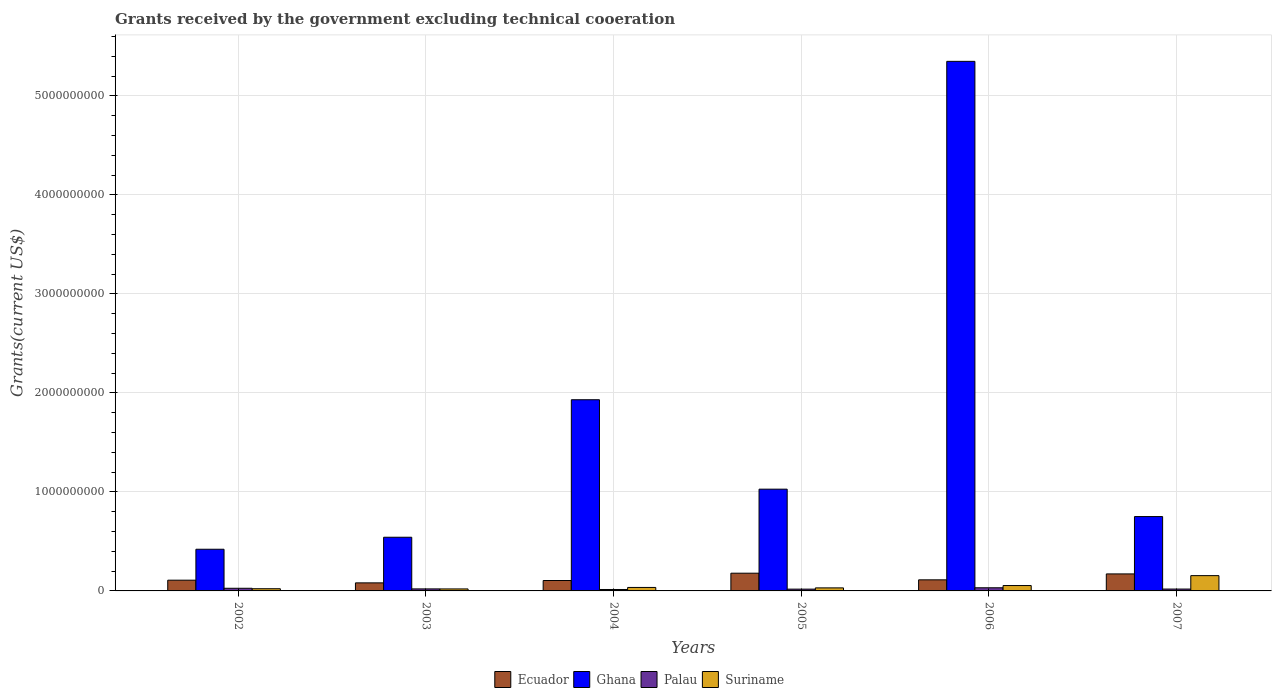How many groups of bars are there?
Keep it short and to the point. 6. Are the number of bars on each tick of the X-axis equal?
Make the answer very short. Yes. How many bars are there on the 4th tick from the left?
Make the answer very short. 4. What is the label of the 1st group of bars from the left?
Your answer should be very brief. 2002. What is the total grants received by the government in Palau in 2004?
Your response must be concise. 1.45e+07. Across all years, what is the maximum total grants received by the government in Palau?
Make the answer very short. 3.17e+07. Across all years, what is the minimum total grants received by the government in Palau?
Offer a very short reply. 1.45e+07. In which year was the total grants received by the government in Ecuador maximum?
Keep it short and to the point. 2005. In which year was the total grants received by the government in Palau minimum?
Your answer should be very brief. 2004. What is the total total grants received by the government in Ghana in the graph?
Provide a succinct answer. 1.00e+1. What is the difference between the total grants received by the government in Suriname in 2003 and that in 2005?
Ensure brevity in your answer.  -1.06e+07. What is the difference between the total grants received by the government in Ghana in 2007 and the total grants received by the government in Ecuador in 2004?
Ensure brevity in your answer.  6.46e+08. What is the average total grants received by the government in Suriname per year?
Keep it short and to the point. 5.28e+07. In the year 2003, what is the difference between the total grants received by the government in Ghana and total grants received by the government in Suriname?
Your response must be concise. 5.22e+08. What is the ratio of the total grants received by the government in Ecuador in 2006 to that in 2007?
Give a very brief answer. 0.65. What is the difference between the highest and the second highest total grants received by the government in Suriname?
Your answer should be compact. 1.00e+08. What is the difference between the highest and the lowest total grants received by the government in Ecuador?
Ensure brevity in your answer.  9.76e+07. What does the 4th bar from the left in 2005 represents?
Your response must be concise. Suriname. Is it the case that in every year, the sum of the total grants received by the government in Suriname and total grants received by the government in Palau is greater than the total grants received by the government in Ghana?
Provide a short and direct response. No. Are all the bars in the graph horizontal?
Your answer should be very brief. No. How many years are there in the graph?
Keep it short and to the point. 6. Does the graph contain grids?
Provide a succinct answer. Yes. How are the legend labels stacked?
Ensure brevity in your answer.  Horizontal. What is the title of the graph?
Your response must be concise. Grants received by the government excluding technical cooeration. What is the label or title of the Y-axis?
Your response must be concise. Grants(current US$). What is the Grants(current US$) of Ecuador in 2002?
Ensure brevity in your answer.  1.08e+08. What is the Grants(current US$) in Ghana in 2002?
Your answer should be very brief. 4.21e+08. What is the Grants(current US$) in Palau in 2002?
Your answer should be compact. 2.68e+07. What is the Grants(current US$) of Suriname in 2002?
Keep it short and to the point. 2.21e+07. What is the Grants(current US$) in Ecuador in 2003?
Keep it short and to the point. 8.14e+07. What is the Grants(current US$) in Ghana in 2003?
Give a very brief answer. 5.42e+08. What is the Grants(current US$) of Palau in 2003?
Give a very brief answer. 2.05e+07. What is the Grants(current US$) in Suriname in 2003?
Offer a very short reply. 2.02e+07. What is the Grants(current US$) in Ecuador in 2004?
Your answer should be very brief. 1.05e+08. What is the Grants(current US$) in Ghana in 2004?
Your answer should be very brief. 1.93e+09. What is the Grants(current US$) of Palau in 2004?
Keep it short and to the point. 1.45e+07. What is the Grants(current US$) of Suriname in 2004?
Provide a short and direct response. 3.52e+07. What is the Grants(current US$) in Ecuador in 2005?
Your answer should be compact. 1.79e+08. What is the Grants(current US$) of Ghana in 2005?
Provide a succinct answer. 1.03e+09. What is the Grants(current US$) in Palau in 2005?
Your answer should be compact. 1.81e+07. What is the Grants(current US$) of Suriname in 2005?
Give a very brief answer. 3.07e+07. What is the Grants(current US$) of Ecuador in 2006?
Provide a short and direct response. 1.12e+08. What is the Grants(current US$) of Ghana in 2006?
Provide a succinct answer. 5.35e+09. What is the Grants(current US$) in Palau in 2006?
Offer a terse response. 3.17e+07. What is the Grants(current US$) in Suriname in 2006?
Ensure brevity in your answer.  5.43e+07. What is the Grants(current US$) in Ecuador in 2007?
Offer a very short reply. 1.72e+08. What is the Grants(current US$) in Ghana in 2007?
Provide a short and direct response. 7.51e+08. What is the Grants(current US$) of Palau in 2007?
Offer a terse response. 1.89e+07. What is the Grants(current US$) of Suriname in 2007?
Keep it short and to the point. 1.54e+08. Across all years, what is the maximum Grants(current US$) of Ecuador?
Make the answer very short. 1.79e+08. Across all years, what is the maximum Grants(current US$) in Ghana?
Provide a succinct answer. 5.35e+09. Across all years, what is the maximum Grants(current US$) of Palau?
Your answer should be compact. 3.17e+07. Across all years, what is the maximum Grants(current US$) of Suriname?
Make the answer very short. 1.54e+08. Across all years, what is the minimum Grants(current US$) in Ecuador?
Make the answer very short. 8.14e+07. Across all years, what is the minimum Grants(current US$) in Ghana?
Ensure brevity in your answer.  4.21e+08. Across all years, what is the minimum Grants(current US$) in Palau?
Make the answer very short. 1.45e+07. Across all years, what is the minimum Grants(current US$) in Suriname?
Offer a very short reply. 2.02e+07. What is the total Grants(current US$) of Ecuador in the graph?
Your answer should be very brief. 7.58e+08. What is the total Grants(current US$) in Ghana in the graph?
Your answer should be compact. 1.00e+1. What is the total Grants(current US$) in Palau in the graph?
Your response must be concise. 1.30e+08. What is the total Grants(current US$) in Suriname in the graph?
Your response must be concise. 3.17e+08. What is the difference between the Grants(current US$) of Ecuador in 2002 and that in 2003?
Make the answer very short. 2.71e+07. What is the difference between the Grants(current US$) in Ghana in 2002 and that in 2003?
Make the answer very short. -1.21e+08. What is the difference between the Grants(current US$) in Palau in 2002 and that in 2003?
Offer a very short reply. 6.28e+06. What is the difference between the Grants(current US$) in Suriname in 2002 and that in 2003?
Provide a succinct answer. 1.93e+06. What is the difference between the Grants(current US$) of Ecuador in 2002 and that in 2004?
Provide a succinct answer. 3.24e+06. What is the difference between the Grants(current US$) of Ghana in 2002 and that in 2004?
Provide a succinct answer. -1.51e+09. What is the difference between the Grants(current US$) in Palau in 2002 and that in 2004?
Your answer should be compact. 1.22e+07. What is the difference between the Grants(current US$) of Suriname in 2002 and that in 2004?
Your answer should be compact. -1.31e+07. What is the difference between the Grants(current US$) in Ecuador in 2002 and that in 2005?
Make the answer very short. -7.05e+07. What is the difference between the Grants(current US$) of Ghana in 2002 and that in 2005?
Your answer should be very brief. -6.07e+08. What is the difference between the Grants(current US$) of Palau in 2002 and that in 2005?
Your response must be concise. 8.67e+06. What is the difference between the Grants(current US$) of Suriname in 2002 and that in 2005?
Offer a very short reply. -8.63e+06. What is the difference between the Grants(current US$) of Ecuador in 2002 and that in 2006?
Offer a very short reply. -3.44e+06. What is the difference between the Grants(current US$) of Ghana in 2002 and that in 2006?
Your answer should be very brief. -4.93e+09. What is the difference between the Grants(current US$) in Palau in 2002 and that in 2006?
Make the answer very short. -4.99e+06. What is the difference between the Grants(current US$) in Suriname in 2002 and that in 2006?
Give a very brief answer. -3.22e+07. What is the difference between the Grants(current US$) of Ecuador in 2002 and that in 2007?
Your response must be concise. -6.33e+07. What is the difference between the Grants(current US$) of Ghana in 2002 and that in 2007?
Your answer should be compact. -3.30e+08. What is the difference between the Grants(current US$) in Palau in 2002 and that in 2007?
Make the answer very short. 7.89e+06. What is the difference between the Grants(current US$) in Suriname in 2002 and that in 2007?
Give a very brief answer. -1.32e+08. What is the difference between the Grants(current US$) of Ecuador in 2003 and that in 2004?
Keep it short and to the point. -2.39e+07. What is the difference between the Grants(current US$) of Ghana in 2003 and that in 2004?
Provide a short and direct response. -1.39e+09. What is the difference between the Grants(current US$) in Palau in 2003 and that in 2004?
Your answer should be compact. 5.96e+06. What is the difference between the Grants(current US$) of Suriname in 2003 and that in 2004?
Give a very brief answer. -1.50e+07. What is the difference between the Grants(current US$) in Ecuador in 2003 and that in 2005?
Your response must be concise. -9.76e+07. What is the difference between the Grants(current US$) in Ghana in 2003 and that in 2005?
Offer a very short reply. -4.85e+08. What is the difference between the Grants(current US$) in Palau in 2003 and that in 2005?
Provide a succinct answer. 2.39e+06. What is the difference between the Grants(current US$) of Suriname in 2003 and that in 2005?
Make the answer very short. -1.06e+07. What is the difference between the Grants(current US$) of Ecuador in 2003 and that in 2006?
Make the answer very short. -3.06e+07. What is the difference between the Grants(current US$) of Ghana in 2003 and that in 2006?
Your response must be concise. -4.81e+09. What is the difference between the Grants(current US$) of Palau in 2003 and that in 2006?
Your response must be concise. -1.13e+07. What is the difference between the Grants(current US$) in Suriname in 2003 and that in 2006?
Provide a short and direct response. -3.42e+07. What is the difference between the Grants(current US$) in Ecuador in 2003 and that in 2007?
Make the answer very short. -9.04e+07. What is the difference between the Grants(current US$) in Ghana in 2003 and that in 2007?
Offer a very short reply. -2.09e+08. What is the difference between the Grants(current US$) of Palau in 2003 and that in 2007?
Your answer should be very brief. 1.61e+06. What is the difference between the Grants(current US$) of Suriname in 2003 and that in 2007?
Your response must be concise. -1.34e+08. What is the difference between the Grants(current US$) in Ecuador in 2004 and that in 2005?
Ensure brevity in your answer.  -7.37e+07. What is the difference between the Grants(current US$) of Ghana in 2004 and that in 2005?
Provide a short and direct response. 9.03e+08. What is the difference between the Grants(current US$) in Palau in 2004 and that in 2005?
Provide a short and direct response. -3.57e+06. What is the difference between the Grants(current US$) in Suriname in 2004 and that in 2005?
Make the answer very short. 4.44e+06. What is the difference between the Grants(current US$) of Ecuador in 2004 and that in 2006?
Give a very brief answer. -6.68e+06. What is the difference between the Grants(current US$) in Ghana in 2004 and that in 2006?
Keep it short and to the point. -3.42e+09. What is the difference between the Grants(current US$) in Palau in 2004 and that in 2006?
Your answer should be compact. -1.72e+07. What is the difference between the Grants(current US$) of Suriname in 2004 and that in 2006?
Your answer should be compact. -1.92e+07. What is the difference between the Grants(current US$) of Ecuador in 2004 and that in 2007?
Your answer should be very brief. -6.65e+07. What is the difference between the Grants(current US$) in Ghana in 2004 and that in 2007?
Your answer should be very brief. 1.18e+09. What is the difference between the Grants(current US$) in Palau in 2004 and that in 2007?
Provide a short and direct response. -4.35e+06. What is the difference between the Grants(current US$) of Suriname in 2004 and that in 2007?
Keep it short and to the point. -1.19e+08. What is the difference between the Grants(current US$) in Ecuador in 2005 and that in 2006?
Provide a short and direct response. 6.70e+07. What is the difference between the Grants(current US$) in Ghana in 2005 and that in 2006?
Offer a terse response. -4.32e+09. What is the difference between the Grants(current US$) in Palau in 2005 and that in 2006?
Offer a terse response. -1.37e+07. What is the difference between the Grants(current US$) in Suriname in 2005 and that in 2006?
Your response must be concise. -2.36e+07. What is the difference between the Grants(current US$) of Ecuador in 2005 and that in 2007?
Keep it short and to the point. 7.21e+06. What is the difference between the Grants(current US$) in Ghana in 2005 and that in 2007?
Provide a succinct answer. 2.77e+08. What is the difference between the Grants(current US$) in Palau in 2005 and that in 2007?
Keep it short and to the point. -7.80e+05. What is the difference between the Grants(current US$) of Suriname in 2005 and that in 2007?
Offer a very short reply. -1.24e+08. What is the difference between the Grants(current US$) in Ecuador in 2006 and that in 2007?
Ensure brevity in your answer.  -5.98e+07. What is the difference between the Grants(current US$) in Ghana in 2006 and that in 2007?
Keep it short and to the point. 4.60e+09. What is the difference between the Grants(current US$) of Palau in 2006 and that in 2007?
Keep it short and to the point. 1.29e+07. What is the difference between the Grants(current US$) in Suriname in 2006 and that in 2007?
Your response must be concise. -1.00e+08. What is the difference between the Grants(current US$) in Ecuador in 2002 and the Grants(current US$) in Ghana in 2003?
Make the answer very short. -4.34e+08. What is the difference between the Grants(current US$) of Ecuador in 2002 and the Grants(current US$) of Palau in 2003?
Keep it short and to the point. 8.80e+07. What is the difference between the Grants(current US$) of Ecuador in 2002 and the Grants(current US$) of Suriname in 2003?
Give a very brief answer. 8.83e+07. What is the difference between the Grants(current US$) of Ghana in 2002 and the Grants(current US$) of Palau in 2003?
Give a very brief answer. 4.00e+08. What is the difference between the Grants(current US$) of Ghana in 2002 and the Grants(current US$) of Suriname in 2003?
Offer a very short reply. 4.01e+08. What is the difference between the Grants(current US$) in Palau in 2002 and the Grants(current US$) in Suriname in 2003?
Make the answer very short. 6.59e+06. What is the difference between the Grants(current US$) in Ecuador in 2002 and the Grants(current US$) in Ghana in 2004?
Give a very brief answer. -1.82e+09. What is the difference between the Grants(current US$) in Ecuador in 2002 and the Grants(current US$) in Palau in 2004?
Provide a succinct answer. 9.40e+07. What is the difference between the Grants(current US$) in Ecuador in 2002 and the Grants(current US$) in Suriname in 2004?
Keep it short and to the point. 7.33e+07. What is the difference between the Grants(current US$) in Ghana in 2002 and the Grants(current US$) in Palau in 2004?
Keep it short and to the point. 4.06e+08. What is the difference between the Grants(current US$) in Ghana in 2002 and the Grants(current US$) in Suriname in 2004?
Your answer should be compact. 3.86e+08. What is the difference between the Grants(current US$) of Palau in 2002 and the Grants(current US$) of Suriname in 2004?
Give a very brief answer. -8.41e+06. What is the difference between the Grants(current US$) in Ecuador in 2002 and the Grants(current US$) in Ghana in 2005?
Your answer should be very brief. -9.19e+08. What is the difference between the Grants(current US$) in Ecuador in 2002 and the Grants(current US$) in Palau in 2005?
Give a very brief answer. 9.04e+07. What is the difference between the Grants(current US$) in Ecuador in 2002 and the Grants(current US$) in Suriname in 2005?
Offer a very short reply. 7.77e+07. What is the difference between the Grants(current US$) in Ghana in 2002 and the Grants(current US$) in Palau in 2005?
Your answer should be compact. 4.03e+08. What is the difference between the Grants(current US$) in Ghana in 2002 and the Grants(current US$) in Suriname in 2005?
Keep it short and to the point. 3.90e+08. What is the difference between the Grants(current US$) of Palau in 2002 and the Grants(current US$) of Suriname in 2005?
Your response must be concise. -3.97e+06. What is the difference between the Grants(current US$) in Ecuador in 2002 and the Grants(current US$) in Ghana in 2006?
Ensure brevity in your answer.  -5.24e+09. What is the difference between the Grants(current US$) of Ecuador in 2002 and the Grants(current US$) of Palau in 2006?
Your answer should be very brief. 7.67e+07. What is the difference between the Grants(current US$) in Ecuador in 2002 and the Grants(current US$) in Suriname in 2006?
Ensure brevity in your answer.  5.41e+07. What is the difference between the Grants(current US$) in Ghana in 2002 and the Grants(current US$) in Palau in 2006?
Your answer should be compact. 3.89e+08. What is the difference between the Grants(current US$) in Ghana in 2002 and the Grants(current US$) in Suriname in 2006?
Provide a short and direct response. 3.67e+08. What is the difference between the Grants(current US$) of Palau in 2002 and the Grants(current US$) of Suriname in 2006?
Offer a terse response. -2.76e+07. What is the difference between the Grants(current US$) of Ecuador in 2002 and the Grants(current US$) of Ghana in 2007?
Offer a terse response. -6.42e+08. What is the difference between the Grants(current US$) in Ecuador in 2002 and the Grants(current US$) in Palau in 2007?
Provide a short and direct response. 8.96e+07. What is the difference between the Grants(current US$) in Ecuador in 2002 and the Grants(current US$) in Suriname in 2007?
Make the answer very short. -4.60e+07. What is the difference between the Grants(current US$) in Ghana in 2002 and the Grants(current US$) in Palau in 2007?
Your response must be concise. 4.02e+08. What is the difference between the Grants(current US$) of Ghana in 2002 and the Grants(current US$) of Suriname in 2007?
Your answer should be compact. 2.66e+08. What is the difference between the Grants(current US$) of Palau in 2002 and the Grants(current US$) of Suriname in 2007?
Your answer should be very brief. -1.28e+08. What is the difference between the Grants(current US$) in Ecuador in 2003 and the Grants(current US$) in Ghana in 2004?
Your answer should be compact. -1.85e+09. What is the difference between the Grants(current US$) of Ecuador in 2003 and the Grants(current US$) of Palau in 2004?
Offer a very short reply. 6.68e+07. What is the difference between the Grants(current US$) of Ecuador in 2003 and the Grants(current US$) of Suriname in 2004?
Your response must be concise. 4.62e+07. What is the difference between the Grants(current US$) of Ghana in 2003 and the Grants(current US$) of Palau in 2004?
Offer a terse response. 5.28e+08. What is the difference between the Grants(current US$) of Ghana in 2003 and the Grants(current US$) of Suriname in 2004?
Give a very brief answer. 5.07e+08. What is the difference between the Grants(current US$) of Palau in 2003 and the Grants(current US$) of Suriname in 2004?
Your answer should be compact. -1.47e+07. What is the difference between the Grants(current US$) in Ecuador in 2003 and the Grants(current US$) in Ghana in 2005?
Provide a succinct answer. -9.46e+08. What is the difference between the Grants(current US$) in Ecuador in 2003 and the Grants(current US$) in Palau in 2005?
Provide a succinct answer. 6.33e+07. What is the difference between the Grants(current US$) in Ecuador in 2003 and the Grants(current US$) in Suriname in 2005?
Keep it short and to the point. 5.06e+07. What is the difference between the Grants(current US$) in Ghana in 2003 and the Grants(current US$) in Palau in 2005?
Provide a succinct answer. 5.24e+08. What is the difference between the Grants(current US$) of Ghana in 2003 and the Grants(current US$) of Suriname in 2005?
Keep it short and to the point. 5.11e+08. What is the difference between the Grants(current US$) of Palau in 2003 and the Grants(current US$) of Suriname in 2005?
Your answer should be compact. -1.02e+07. What is the difference between the Grants(current US$) of Ecuador in 2003 and the Grants(current US$) of Ghana in 2006?
Keep it short and to the point. -5.27e+09. What is the difference between the Grants(current US$) in Ecuador in 2003 and the Grants(current US$) in Palau in 2006?
Provide a short and direct response. 4.96e+07. What is the difference between the Grants(current US$) of Ecuador in 2003 and the Grants(current US$) of Suriname in 2006?
Make the answer very short. 2.70e+07. What is the difference between the Grants(current US$) in Ghana in 2003 and the Grants(current US$) in Palau in 2006?
Your response must be concise. 5.10e+08. What is the difference between the Grants(current US$) in Ghana in 2003 and the Grants(current US$) in Suriname in 2006?
Keep it short and to the point. 4.88e+08. What is the difference between the Grants(current US$) in Palau in 2003 and the Grants(current US$) in Suriname in 2006?
Your answer should be compact. -3.38e+07. What is the difference between the Grants(current US$) in Ecuador in 2003 and the Grants(current US$) in Ghana in 2007?
Offer a very short reply. -6.70e+08. What is the difference between the Grants(current US$) of Ecuador in 2003 and the Grants(current US$) of Palau in 2007?
Your answer should be compact. 6.25e+07. What is the difference between the Grants(current US$) of Ecuador in 2003 and the Grants(current US$) of Suriname in 2007?
Give a very brief answer. -7.31e+07. What is the difference between the Grants(current US$) in Ghana in 2003 and the Grants(current US$) in Palau in 2007?
Provide a succinct answer. 5.23e+08. What is the difference between the Grants(current US$) of Ghana in 2003 and the Grants(current US$) of Suriname in 2007?
Offer a very short reply. 3.88e+08. What is the difference between the Grants(current US$) of Palau in 2003 and the Grants(current US$) of Suriname in 2007?
Your answer should be compact. -1.34e+08. What is the difference between the Grants(current US$) of Ecuador in 2004 and the Grants(current US$) of Ghana in 2005?
Your response must be concise. -9.22e+08. What is the difference between the Grants(current US$) in Ecuador in 2004 and the Grants(current US$) in Palau in 2005?
Keep it short and to the point. 8.71e+07. What is the difference between the Grants(current US$) of Ecuador in 2004 and the Grants(current US$) of Suriname in 2005?
Ensure brevity in your answer.  7.45e+07. What is the difference between the Grants(current US$) in Ghana in 2004 and the Grants(current US$) in Palau in 2005?
Offer a very short reply. 1.91e+09. What is the difference between the Grants(current US$) of Ghana in 2004 and the Grants(current US$) of Suriname in 2005?
Your answer should be compact. 1.90e+09. What is the difference between the Grants(current US$) of Palau in 2004 and the Grants(current US$) of Suriname in 2005?
Make the answer very short. -1.62e+07. What is the difference between the Grants(current US$) of Ecuador in 2004 and the Grants(current US$) of Ghana in 2006?
Provide a succinct answer. -5.24e+09. What is the difference between the Grants(current US$) in Ecuador in 2004 and the Grants(current US$) in Palau in 2006?
Keep it short and to the point. 7.35e+07. What is the difference between the Grants(current US$) of Ecuador in 2004 and the Grants(current US$) of Suriname in 2006?
Provide a succinct answer. 5.09e+07. What is the difference between the Grants(current US$) in Ghana in 2004 and the Grants(current US$) in Palau in 2006?
Offer a very short reply. 1.90e+09. What is the difference between the Grants(current US$) in Ghana in 2004 and the Grants(current US$) in Suriname in 2006?
Ensure brevity in your answer.  1.88e+09. What is the difference between the Grants(current US$) of Palau in 2004 and the Grants(current US$) of Suriname in 2006?
Your answer should be very brief. -3.98e+07. What is the difference between the Grants(current US$) in Ecuador in 2004 and the Grants(current US$) in Ghana in 2007?
Your answer should be very brief. -6.46e+08. What is the difference between the Grants(current US$) of Ecuador in 2004 and the Grants(current US$) of Palau in 2007?
Give a very brief answer. 8.64e+07. What is the difference between the Grants(current US$) of Ecuador in 2004 and the Grants(current US$) of Suriname in 2007?
Your response must be concise. -4.92e+07. What is the difference between the Grants(current US$) of Ghana in 2004 and the Grants(current US$) of Palau in 2007?
Your response must be concise. 1.91e+09. What is the difference between the Grants(current US$) in Ghana in 2004 and the Grants(current US$) in Suriname in 2007?
Provide a succinct answer. 1.78e+09. What is the difference between the Grants(current US$) of Palau in 2004 and the Grants(current US$) of Suriname in 2007?
Give a very brief answer. -1.40e+08. What is the difference between the Grants(current US$) of Ecuador in 2005 and the Grants(current US$) of Ghana in 2006?
Give a very brief answer. -5.17e+09. What is the difference between the Grants(current US$) in Ecuador in 2005 and the Grants(current US$) in Palau in 2006?
Give a very brief answer. 1.47e+08. What is the difference between the Grants(current US$) in Ecuador in 2005 and the Grants(current US$) in Suriname in 2006?
Your response must be concise. 1.25e+08. What is the difference between the Grants(current US$) in Ghana in 2005 and the Grants(current US$) in Palau in 2006?
Your response must be concise. 9.96e+08. What is the difference between the Grants(current US$) in Ghana in 2005 and the Grants(current US$) in Suriname in 2006?
Offer a terse response. 9.73e+08. What is the difference between the Grants(current US$) of Palau in 2005 and the Grants(current US$) of Suriname in 2006?
Provide a short and direct response. -3.62e+07. What is the difference between the Grants(current US$) of Ecuador in 2005 and the Grants(current US$) of Ghana in 2007?
Give a very brief answer. -5.72e+08. What is the difference between the Grants(current US$) of Ecuador in 2005 and the Grants(current US$) of Palau in 2007?
Provide a short and direct response. 1.60e+08. What is the difference between the Grants(current US$) of Ecuador in 2005 and the Grants(current US$) of Suriname in 2007?
Your answer should be very brief. 2.45e+07. What is the difference between the Grants(current US$) of Ghana in 2005 and the Grants(current US$) of Palau in 2007?
Make the answer very short. 1.01e+09. What is the difference between the Grants(current US$) of Ghana in 2005 and the Grants(current US$) of Suriname in 2007?
Give a very brief answer. 8.73e+08. What is the difference between the Grants(current US$) of Palau in 2005 and the Grants(current US$) of Suriname in 2007?
Keep it short and to the point. -1.36e+08. What is the difference between the Grants(current US$) of Ecuador in 2006 and the Grants(current US$) of Ghana in 2007?
Your answer should be very brief. -6.39e+08. What is the difference between the Grants(current US$) of Ecuador in 2006 and the Grants(current US$) of Palau in 2007?
Your answer should be very brief. 9.30e+07. What is the difference between the Grants(current US$) in Ecuador in 2006 and the Grants(current US$) in Suriname in 2007?
Make the answer very short. -4.26e+07. What is the difference between the Grants(current US$) of Ghana in 2006 and the Grants(current US$) of Palau in 2007?
Your answer should be very brief. 5.33e+09. What is the difference between the Grants(current US$) of Ghana in 2006 and the Grants(current US$) of Suriname in 2007?
Offer a terse response. 5.19e+09. What is the difference between the Grants(current US$) in Palau in 2006 and the Grants(current US$) in Suriname in 2007?
Make the answer very short. -1.23e+08. What is the average Grants(current US$) of Ecuador per year?
Your answer should be compact. 1.26e+08. What is the average Grants(current US$) in Ghana per year?
Make the answer very short. 1.67e+09. What is the average Grants(current US$) of Palau per year?
Make the answer very short. 2.17e+07. What is the average Grants(current US$) of Suriname per year?
Your answer should be compact. 5.28e+07. In the year 2002, what is the difference between the Grants(current US$) of Ecuador and Grants(current US$) of Ghana?
Provide a short and direct response. -3.12e+08. In the year 2002, what is the difference between the Grants(current US$) of Ecuador and Grants(current US$) of Palau?
Keep it short and to the point. 8.17e+07. In the year 2002, what is the difference between the Grants(current US$) of Ecuador and Grants(current US$) of Suriname?
Provide a short and direct response. 8.64e+07. In the year 2002, what is the difference between the Grants(current US$) of Ghana and Grants(current US$) of Palau?
Provide a short and direct response. 3.94e+08. In the year 2002, what is the difference between the Grants(current US$) of Ghana and Grants(current US$) of Suriname?
Keep it short and to the point. 3.99e+08. In the year 2002, what is the difference between the Grants(current US$) of Palau and Grants(current US$) of Suriname?
Ensure brevity in your answer.  4.66e+06. In the year 2003, what is the difference between the Grants(current US$) in Ecuador and Grants(current US$) in Ghana?
Provide a succinct answer. -4.61e+08. In the year 2003, what is the difference between the Grants(current US$) of Ecuador and Grants(current US$) of Palau?
Offer a terse response. 6.09e+07. In the year 2003, what is the difference between the Grants(current US$) of Ecuador and Grants(current US$) of Suriname?
Give a very brief answer. 6.12e+07. In the year 2003, what is the difference between the Grants(current US$) of Ghana and Grants(current US$) of Palau?
Your response must be concise. 5.22e+08. In the year 2003, what is the difference between the Grants(current US$) of Ghana and Grants(current US$) of Suriname?
Give a very brief answer. 5.22e+08. In the year 2004, what is the difference between the Grants(current US$) in Ecuador and Grants(current US$) in Ghana?
Give a very brief answer. -1.83e+09. In the year 2004, what is the difference between the Grants(current US$) in Ecuador and Grants(current US$) in Palau?
Your answer should be very brief. 9.07e+07. In the year 2004, what is the difference between the Grants(current US$) in Ecuador and Grants(current US$) in Suriname?
Offer a very short reply. 7.01e+07. In the year 2004, what is the difference between the Grants(current US$) in Ghana and Grants(current US$) in Palau?
Give a very brief answer. 1.92e+09. In the year 2004, what is the difference between the Grants(current US$) of Ghana and Grants(current US$) of Suriname?
Give a very brief answer. 1.90e+09. In the year 2004, what is the difference between the Grants(current US$) in Palau and Grants(current US$) in Suriname?
Offer a very short reply. -2.06e+07. In the year 2005, what is the difference between the Grants(current US$) of Ecuador and Grants(current US$) of Ghana?
Your response must be concise. -8.49e+08. In the year 2005, what is the difference between the Grants(current US$) of Ecuador and Grants(current US$) of Palau?
Keep it short and to the point. 1.61e+08. In the year 2005, what is the difference between the Grants(current US$) in Ecuador and Grants(current US$) in Suriname?
Provide a succinct answer. 1.48e+08. In the year 2005, what is the difference between the Grants(current US$) in Ghana and Grants(current US$) in Palau?
Make the answer very short. 1.01e+09. In the year 2005, what is the difference between the Grants(current US$) in Ghana and Grants(current US$) in Suriname?
Give a very brief answer. 9.97e+08. In the year 2005, what is the difference between the Grants(current US$) in Palau and Grants(current US$) in Suriname?
Provide a succinct answer. -1.26e+07. In the year 2006, what is the difference between the Grants(current US$) of Ecuador and Grants(current US$) of Ghana?
Your answer should be compact. -5.24e+09. In the year 2006, what is the difference between the Grants(current US$) of Ecuador and Grants(current US$) of Palau?
Your response must be concise. 8.02e+07. In the year 2006, what is the difference between the Grants(current US$) of Ecuador and Grants(current US$) of Suriname?
Give a very brief answer. 5.76e+07. In the year 2006, what is the difference between the Grants(current US$) in Ghana and Grants(current US$) in Palau?
Your response must be concise. 5.32e+09. In the year 2006, what is the difference between the Grants(current US$) in Ghana and Grants(current US$) in Suriname?
Your response must be concise. 5.29e+09. In the year 2006, what is the difference between the Grants(current US$) of Palau and Grants(current US$) of Suriname?
Provide a short and direct response. -2.26e+07. In the year 2007, what is the difference between the Grants(current US$) of Ecuador and Grants(current US$) of Ghana?
Provide a short and direct response. -5.79e+08. In the year 2007, what is the difference between the Grants(current US$) of Ecuador and Grants(current US$) of Palau?
Ensure brevity in your answer.  1.53e+08. In the year 2007, what is the difference between the Grants(current US$) of Ecuador and Grants(current US$) of Suriname?
Your answer should be compact. 1.73e+07. In the year 2007, what is the difference between the Grants(current US$) of Ghana and Grants(current US$) of Palau?
Ensure brevity in your answer.  7.32e+08. In the year 2007, what is the difference between the Grants(current US$) of Ghana and Grants(current US$) of Suriname?
Provide a short and direct response. 5.96e+08. In the year 2007, what is the difference between the Grants(current US$) of Palau and Grants(current US$) of Suriname?
Ensure brevity in your answer.  -1.36e+08. What is the ratio of the Grants(current US$) of Ghana in 2002 to that in 2003?
Provide a short and direct response. 0.78. What is the ratio of the Grants(current US$) in Palau in 2002 to that in 2003?
Provide a succinct answer. 1.31. What is the ratio of the Grants(current US$) in Suriname in 2002 to that in 2003?
Offer a very short reply. 1.1. What is the ratio of the Grants(current US$) of Ecuador in 2002 to that in 2004?
Provide a succinct answer. 1.03. What is the ratio of the Grants(current US$) in Ghana in 2002 to that in 2004?
Ensure brevity in your answer.  0.22. What is the ratio of the Grants(current US$) of Palau in 2002 to that in 2004?
Your response must be concise. 1.84. What is the ratio of the Grants(current US$) in Suriname in 2002 to that in 2004?
Your answer should be very brief. 0.63. What is the ratio of the Grants(current US$) of Ecuador in 2002 to that in 2005?
Offer a terse response. 0.61. What is the ratio of the Grants(current US$) in Ghana in 2002 to that in 2005?
Ensure brevity in your answer.  0.41. What is the ratio of the Grants(current US$) of Palau in 2002 to that in 2005?
Offer a terse response. 1.48. What is the ratio of the Grants(current US$) of Suriname in 2002 to that in 2005?
Provide a short and direct response. 0.72. What is the ratio of the Grants(current US$) in Ecuador in 2002 to that in 2006?
Make the answer very short. 0.97. What is the ratio of the Grants(current US$) of Ghana in 2002 to that in 2006?
Your response must be concise. 0.08. What is the ratio of the Grants(current US$) of Palau in 2002 to that in 2006?
Your response must be concise. 0.84. What is the ratio of the Grants(current US$) in Suriname in 2002 to that in 2006?
Offer a terse response. 0.41. What is the ratio of the Grants(current US$) in Ecuador in 2002 to that in 2007?
Your answer should be compact. 0.63. What is the ratio of the Grants(current US$) in Ghana in 2002 to that in 2007?
Your answer should be very brief. 0.56. What is the ratio of the Grants(current US$) of Palau in 2002 to that in 2007?
Offer a terse response. 1.42. What is the ratio of the Grants(current US$) of Suriname in 2002 to that in 2007?
Offer a terse response. 0.14. What is the ratio of the Grants(current US$) of Ecuador in 2003 to that in 2004?
Make the answer very short. 0.77. What is the ratio of the Grants(current US$) in Ghana in 2003 to that in 2004?
Your answer should be very brief. 0.28. What is the ratio of the Grants(current US$) in Palau in 2003 to that in 2004?
Your response must be concise. 1.41. What is the ratio of the Grants(current US$) in Suriname in 2003 to that in 2004?
Keep it short and to the point. 0.57. What is the ratio of the Grants(current US$) of Ecuador in 2003 to that in 2005?
Make the answer very short. 0.45. What is the ratio of the Grants(current US$) of Ghana in 2003 to that in 2005?
Provide a short and direct response. 0.53. What is the ratio of the Grants(current US$) of Palau in 2003 to that in 2005?
Your response must be concise. 1.13. What is the ratio of the Grants(current US$) in Suriname in 2003 to that in 2005?
Make the answer very short. 0.66. What is the ratio of the Grants(current US$) in Ecuador in 2003 to that in 2006?
Provide a succinct answer. 0.73. What is the ratio of the Grants(current US$) in Ghana in 2003 to that in 2006?
Provide a succinct answer. 0.1. What is the ratio of the Grants(current US$) in Palau in 2003 to that in 2006?
Keep it short and to the point. 0.64. What is the ratio of the Grants(current US$) in Suriname in 2003 to that in 2006?
Give a very brief answer. 0.37. What is the ratio of the Grants(current US$) of Ecuador in 2003 to that in 2007?
Your answer should be very brief. 0.47. What is the ratio of the Grants(current US$) in Ghana in 2003 to that in 2007?
Your answer should be very brief. 0.72. What is the ratio of the Grants(current US$) in Palau in 2003 to that in 2007?
Provide a succinct answer. 1.09. What is the ratio of the Grants(current US$) of Suriname in 2003 to that in 2007?
Give a very brief answer. 0.13. What is the ratio of the Grants(current US$) of Ecuador in 2004 to that in 2005?
Make the answer very short. 0.59. What is the ratio of the Grants(current US$) of Ghana in 2004 to that in 2005?
Offer a very short reply. 1.88. What is the ratio of the Grants(current US$) of Palau in 2004 to that in 2005?
Offer a terse response. 0.8. What is the ratio of the Grants(current US$) of Suriname in 2004 to that in 2005?
Keep it short and to the point. 1.14. What is the ratio of the Grants(current US$) of Ecuador in 2004 to that in 2006?
Provide a succinct answer. 0.94. What is the ratio of the Grants(current US$) in Ghana in 2004 to that in 2006?
Your answer should be very brief. 0.36. What is the ratio of the Grants(current US$) in Palau in 2004 to that in 2006?
Give a very brief answer. 0.46. What is the ratio of the Grants(current US$) of Suriname in 2004 to that in 2006?
Offer a terse response. 0.65. What is the ratio of the Grants(current US$) in Ecuador in 2004 to that in 2007?
Provide a succinct answer. 0.61. What is the ratio of the Grants(current US$) of Ghana in 2004 to that in 2007?
Offer a very short reply. 2.57. What is the ratio of the Grants(current US$) in Palau in 2004 to that in 2007?
Ensure brevity in your answer.  0.77. What is the ratio of the Grants(current US$) of Suriname in 2004 to that in 2007?
Your answer should be very brief. 0.23. What is the ratio of the Grants(current US$) of Ecuador in 2005 to that in 2006?
Give a very brief answer. 1.6. What is the ratio of the Grants(current US$) in Ghana in 2005 to that in 2006?
Your response must be concise. 0.19. What is the ratio of the Grants(current US$) in Palau in 2005 to that in 2006?
Your answer should be compact. 0.57. What is the ratio of the Grants(current US$) in Suriname in 2005 to that in 2006?
Your answer should be compact. 0.57. What is the ratio of the Grants(current US$) of Ecuador in 2005 to that in 2007?
Offer a terse response. 1.04. What is the ratio of the Grants(current US$) of Ghana in 2005 to that in 2007?
Make the answer very short. 1.37. What is the ratio of the Grants(current US$) of Palau in 2005 to that in 2007?
Provide a short and direct response. 0.96. What is the ratio of the Grants(current US$) in Suriname in 2005 to that in 2007?
Keep it short and to the point. 0.2. What is the ratio of the Grants(current US$) in Ecuador in 2006 to that in 2007?
Offer a very short reply. 0.65. What is the ratio of the Grants(current US$) in Ghana in 2006 to that in 2007?
Offer a very short reply. 7.12. What is the ratio of the Grants(current US$) of Palau in 2006 to that in 2007?
Offer a terse response. 1.68. What is the ratio of the Grants(current US$) in Suriname in 2006 to that in 2007?
Your answer should be compact. 0.35. What is the difference between the highest and the second highest Grants(current US$) in Ecuador?
Provide a succinct answer. 7.21e+06. What is the difference between the highest and the second highest Grants(current US$) of Ghana?
Offer a terse response. 3.42e+09. What is the difference between the highest and the second highest Grants(current US$) of Palau?
Your answer should be very brief. 4.99e+06. What is the difference between the highest and the second highest Grants(current US$) of Suriname?
Offer a very short reply. 1.00e+08. What is the difference between the highest and the lowest Grants(current US$) of Ecuador?
Your response must be concise. 9.76e+07. What is the difference between the highest and the lowest Grants(current US$) of Ghana?
Provide a succinct answer. 4.93e+09. What is the difference between the highest and the lowest Grants(current US$) in Palau?
Your answer should be compact. 1.72e+07. What is the difference between the highest and the lowest Grants(current US$) of Suriname?
Offer a terse response. 1.34e+08. 